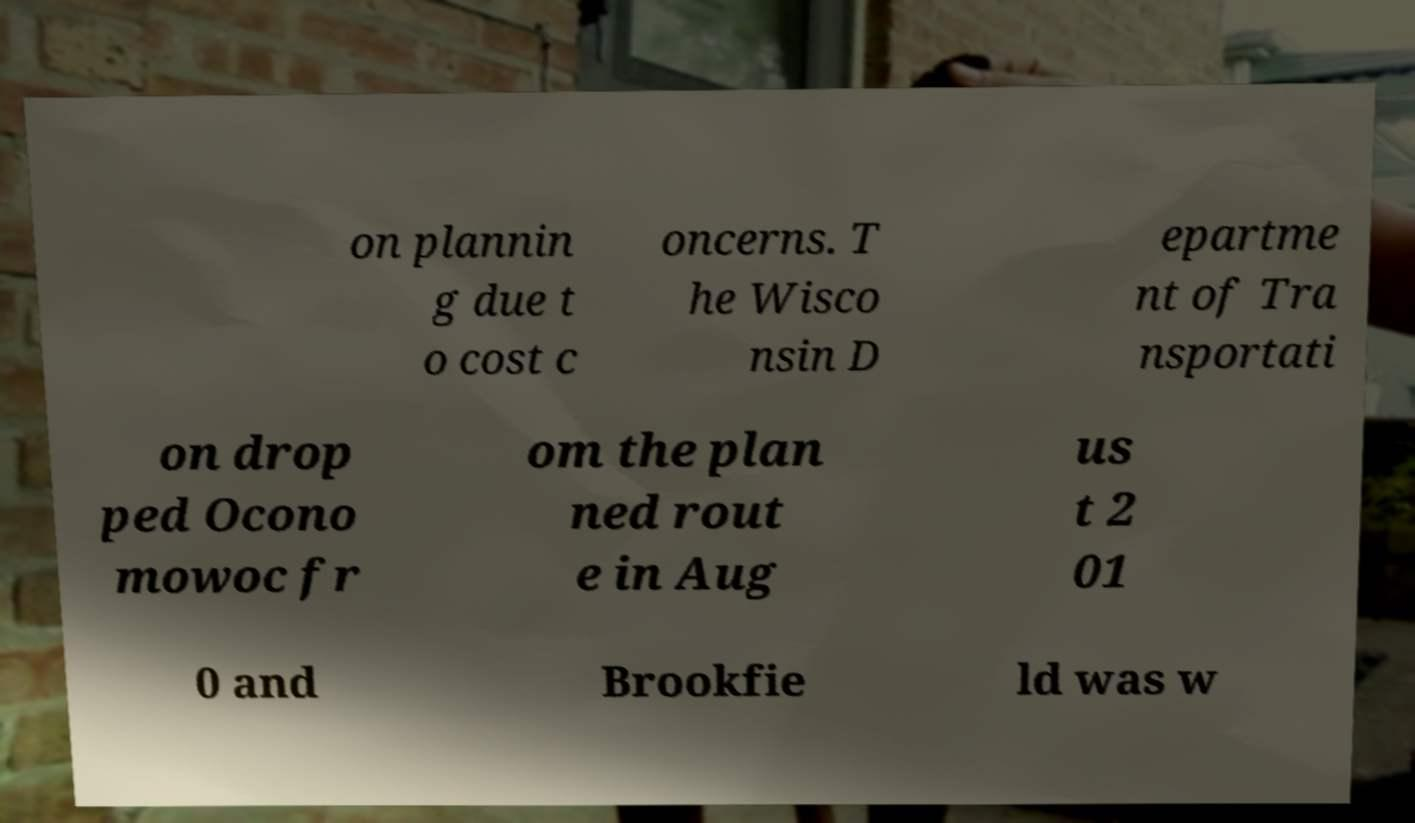What messages or text are displayed in this image? I need them in a readable, typed format. on plannin g due t o cost c oncerns. T he Wisco nsin D epartme nt of Tra nsportati on drop ped Ocono mowoc fr om the plan ned rout e in Aug us t 2 01 0 and Brookfie ld was w 